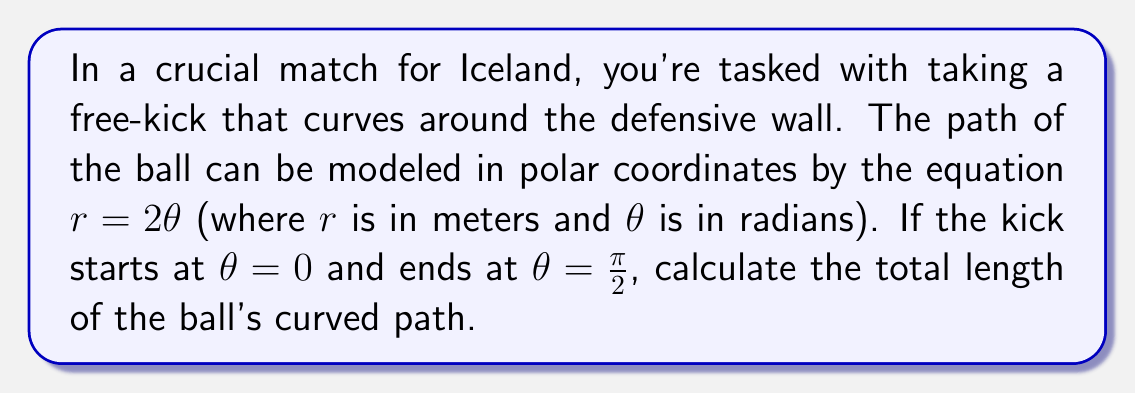Can you solve this math problem? To solve this problem, we'll use the polar arc length formula:

$$ L = \int_a^b \sqrt{r^2 + \left(\frac{dr}{d\theta}\right)^2} d\theta $$

Given:
- The polar equation of the path: $r = 2\theta$
- Start angle: $a = 0$
- End angle: $b = \frac{\pi}{2}$

Steps:
1) First, we need to find $\frac{dr}{d\theta}$:
   $\frac{dr}{d\theta} = 2$

2) Now, let's substitute these into the arc length formula:
   $$ L = \int_0^{\frac{\pi}{2}} \sqrt{(2\theta)^2 + (2)^2} d\theta $$

3) Simplify under the square root:
   $$ L = \int_0^{\frac{\pi}{2}} \sqrt{4\theta^2 + 4} d\theta $$
   $$ L = 2\int_0^{\frac{\pi}{2}} \sqrt{\theta^2 + 1} d\theta $$

4) This integral can be solved using the substitution $\theta = \sinh u$:
   $$ L = 2\int_0^{\sinh^{-1}(\frac{\pi}{2})} \sqrt{\sinh^2 u + 1} \cosh u du $$
   $$ L = 2\int_0^{\sinh^{-1}(\frac{\pi}{2})} \cosh^2 u du $$

5) Using the identity $\cosh^2 u = \frac{1}{2}(\cosh 2u + 1)$:
   $$ L = \int_0^{\sinh^{-1}(\frac{\pi}{2})} (\cosh 2u + 1) du $$
   $$ L = \left[\frac{1}{2}\sinh 2u + u\right]_0^{\sinh^{-1}(\frac{\pi}{2})} $$

6) Evaluate the integral:
   $$ L = \frac{1}{2}\sinh(2\sinh^{-1}(\frac{\pi}{2})) + \sinh^{-1}(\frac{\pi}{2}) $$

7) Simplify using hyperbolic function identities:
   $$ L = \frac{1}{2}\frac{\pi}{2}\sqrt{\frac{\pi^2}{4}+1} + \sinh^{-1}(\frac{\pi}{2}) $$

8) Calculate the numerical value:
   $$ L \approx 2.76 \text{ meters} $$
Answer: The length of the curved free-kick path is approximately 2.76 meters. 